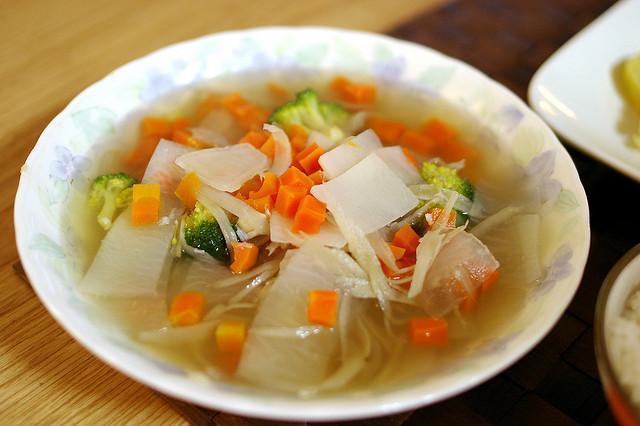How many carrots can be seen?
Give a very brief answer. 2. How many broccolis can be seen?
Give a very brief answer. 2. 